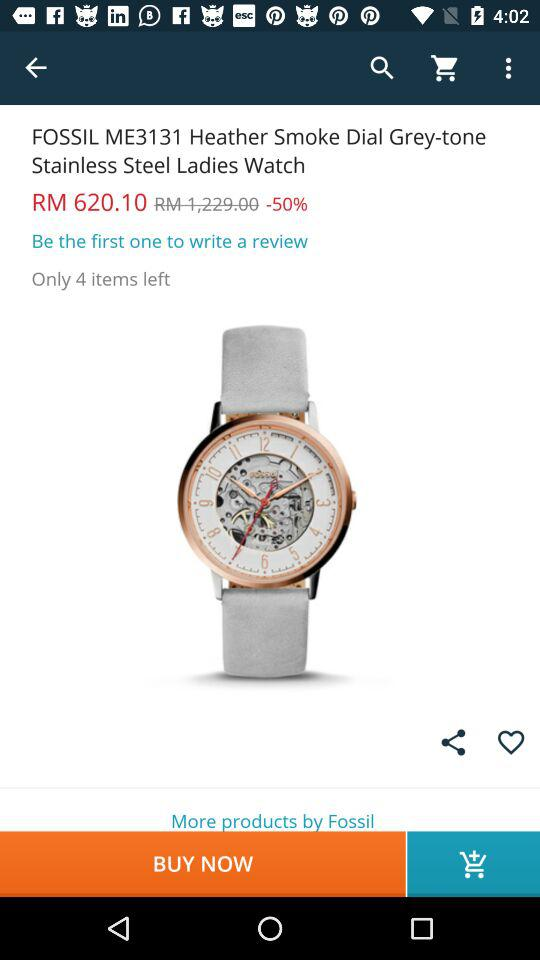How many items are left? There are 4 items left. 